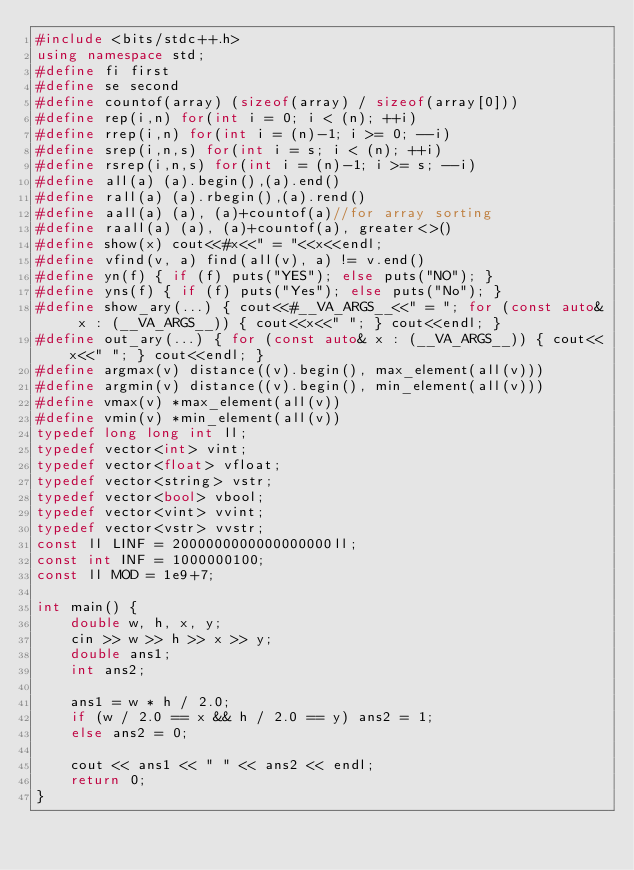Convert code to text. <code><loc_0><loc_0><loc_500><loc_500><_C++_>#include <bits/stdc++.h>
using namespace std;
#define fi first
#define se second
#define countof(array) (sizeof(array) / sizeof(array[0]))
#define rep(i,n) for(int i = 0; i < (n); ++i)
#define rrep(i,n) for(int i = (n)-1; i >= 0; --i)
#define srep(i,n,s) for(int i = s; i < (n); ++i)
#define rsrep(i,n,s) for(int i = (n)-1; i >= s; --i)
#define all(a) (a).begin(),(a).end()
#define rall(a) (a).rbegin(),(a).rend()
#define aall(a) (a), (a)+countof(a)//for array sorting
#define raall(a) (a), (a)+countof(a), greater<>()
#define show(x) cout<<#x<<" = "<<x<<endl;
#define vfind(v, a) find(all(v), a) != v.end()
#define yn(f) { if (f) puts("YES"); else puts("NO"); }
#define yns(f) { if (f) puts("Yes"); else puts("No"); }
#define show_ary(...) { cout<<#__VA_ARGS__<<" = "; for (const auto& x : (__VA_ARGS__)) { cout<<x<<" "; } cout<<endl; }
#define out_ary(...) { for (const auto& x : (__VA_ARGS__)) { cout<<x<<" "; } cout<<endl; }
#define argmax(v) distance((v).begin(), max_element(all(v)))
#define argmin(v) distance((v).begin(), min_element(all(v)))
#define vmax(v) *max_element(all(v))
#define vmin(v) *min_element(all(v))
typedef long long int ll;
typedef vector<int> vint;
typedef vector<float> vfloat;
typedef vector<string> vstr;
typedef vector<bool> vbool;
typedef vector<vint> vvint;
typedef vector<vstr> vvstr;
const ll LINF = 2000000000000000000ll;
const int INF = 1000000100;
const ll MOD = 1e9+7;

int main() {
    double w, h, x, y;
    cin >> w >> h >> x >> y;
    double ans1;
    int ans2;

    ans1 = w * h / 2.0;
    if (w / 2.0 == x && h / 2.0 == y) ans2 = 1;
    else ans2 = 0;

    cout << ans1 << " " << ans2 << endl;
    return 0;
}</code> 